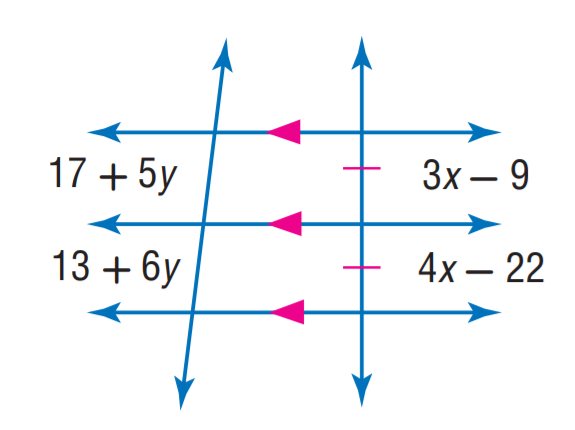Answer the mathemtical geometry problem and directly provide the correct option letter.
Question: Find y.
Choices: A: 3 B: 4 C: 6 D: 9 B 